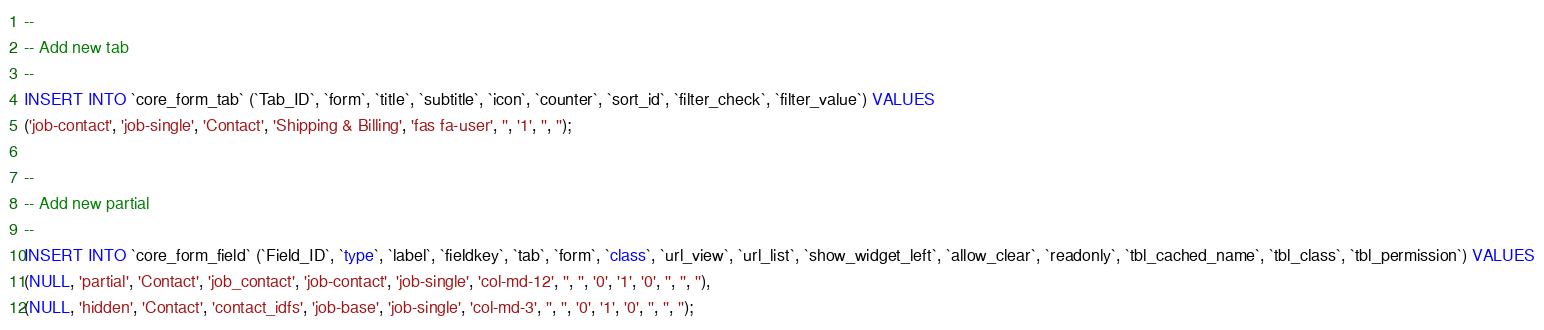Convert code to text. <code><loc_0><loc_0><loc_500><loc_500><_SQL_>--
-- Add new tab
--
INSERT INTO `core_form_tab` (`Tab_ID`, `form`, `title`, `subtitle`, `icon`, `counter`, `sort_id`, `filter_check`, `filter_value`) VALUES
('job-contact', 'job-single', 'Contact', 'Shipping & Billing', 'fas fa-user', '', '1', '', '');

--
-- Add new partial
--
INSERT INTO `core_form_field` (`Field_ID`, `type`, `label`, `fieldkey`, `tab`, `form`, `class`, `url_view`, `url_list`, `show_widget_left`, `allow_clear`, `readonly`, `tbl_cached_name`, `tbl_class`, `tbl_permission`) VALUES
(NULL, 'partial', 'Contact', 'job_contact', 'job-contact', 'job-single', 'col-md-12', '', '', '0', '1', '0', '', '', ''),
(NULL, 'hidden', 'Contact', 'contact_idfs', 'job-base', 'job-single', 'col-md-3', '', '', '0', '1', '0', '', '', '');</code> 